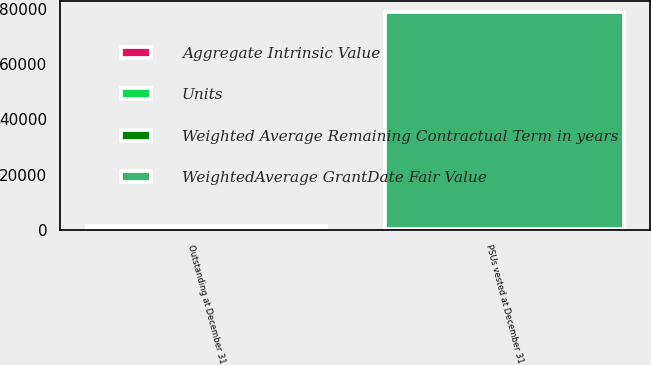Convert chart. <chart><loc_0><loc_0><loc_500><loc_500><stacked_bar_chart><ecel><fcel>Outstanding at December 31<fcel>PSUs vested at December 31<nl><fcel>Units<fcel>1027<fcel>305<nl><fcel>Aggregate Intrinsic Value<fcel>145<fcel>141<nl><fcel>Weighted Average Remaining Contractual Term in years<fcel>0.7<fcel>0.7<nl><fcel>WeightedAverage GrantDate Fair Value<fcel>145<fcel>78170<nl></chart> 